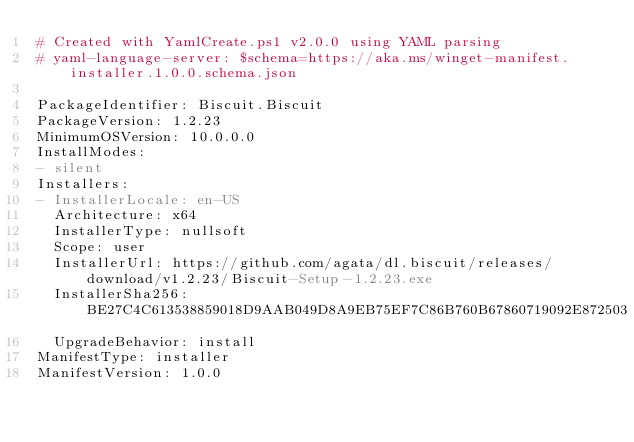Convert code to text. <code><loc_0><loc_0><loc_500><loc_500><_YAML_># Created with YamlCreate.ps1 v2.0.0 using YAML parsing
# yaml-language-server: $schema=https://aka.ms/winget-manifest.installer.1.0.0.schema.json

PackageIdentifier: Biscuit.Biscuit
PackageVersion: 1.2.23
MinimumOSVersion: 10.0.0.0
InstallModes:
- silent
Installers:
- InstallerLocale: en-US
  Architecture: x64
  InstallerType: nullsoft
  Scope: user
  InstallerUrl: https://github.com/agata/dl.biscuit/releases/download/v1.2.23/Biscuit-Setup-1.2.23.exe
  InstallerSha256: BE27C4C613538859018D9AAB049D8A9EB75EF7C86B760B67860719092E872503
  UpgradeBehavior: install
ManifestType: installer
ManifestVersion: 1.0.0
</code> 